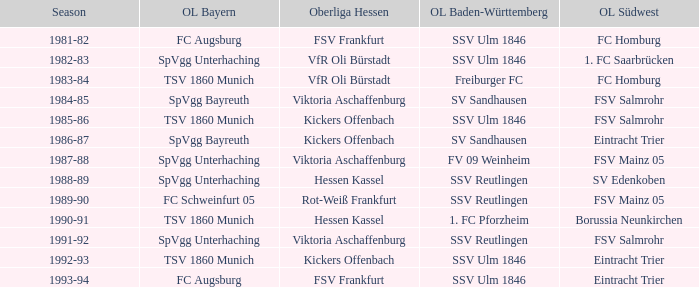Which oberliga baden-württemberg has a season of 1991-92? SSV Reutlingen. 